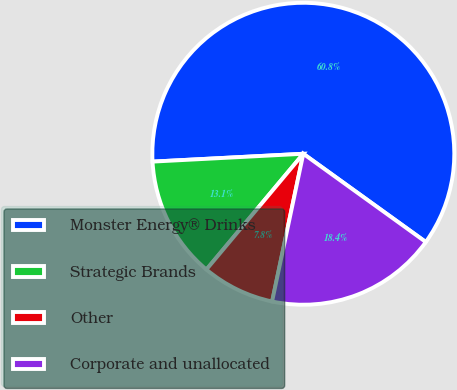<chart> <loc_0><loc_0><loc_500><loc_500><pie_chart><fcel>Monster Energy® Drinks<fcel>Strategic Brands<fcel>Other<fcel>Corporate and unallocated<nl><fcel>60.77%<fcel>13.08%<fcel>7.78%<fcel>18.38%<nl></chart> 